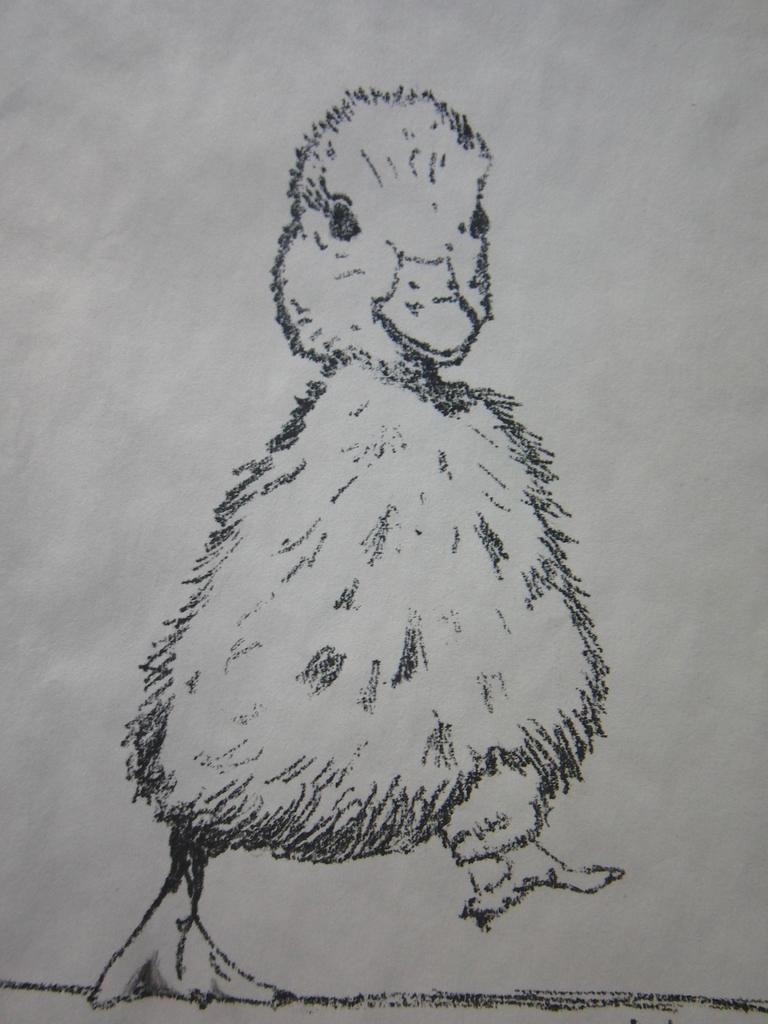In one or two sentences, can you explain what this image depicts? In the image we can see the drawing of an animal on the white paper. 